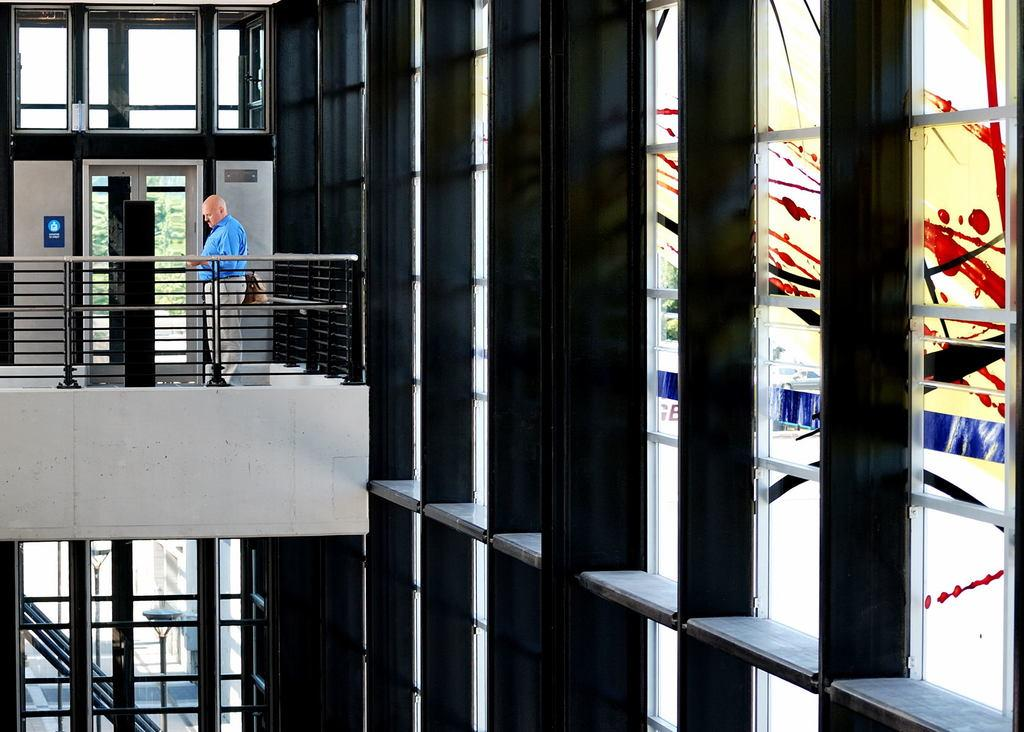Where was the image taken from? The image was taken from inside a building. What can be seen in the image from inside the building? There is a person standing in the balcony. What request did the grandfather make in the image? There is no mention of a grandfather or any request in the image. 